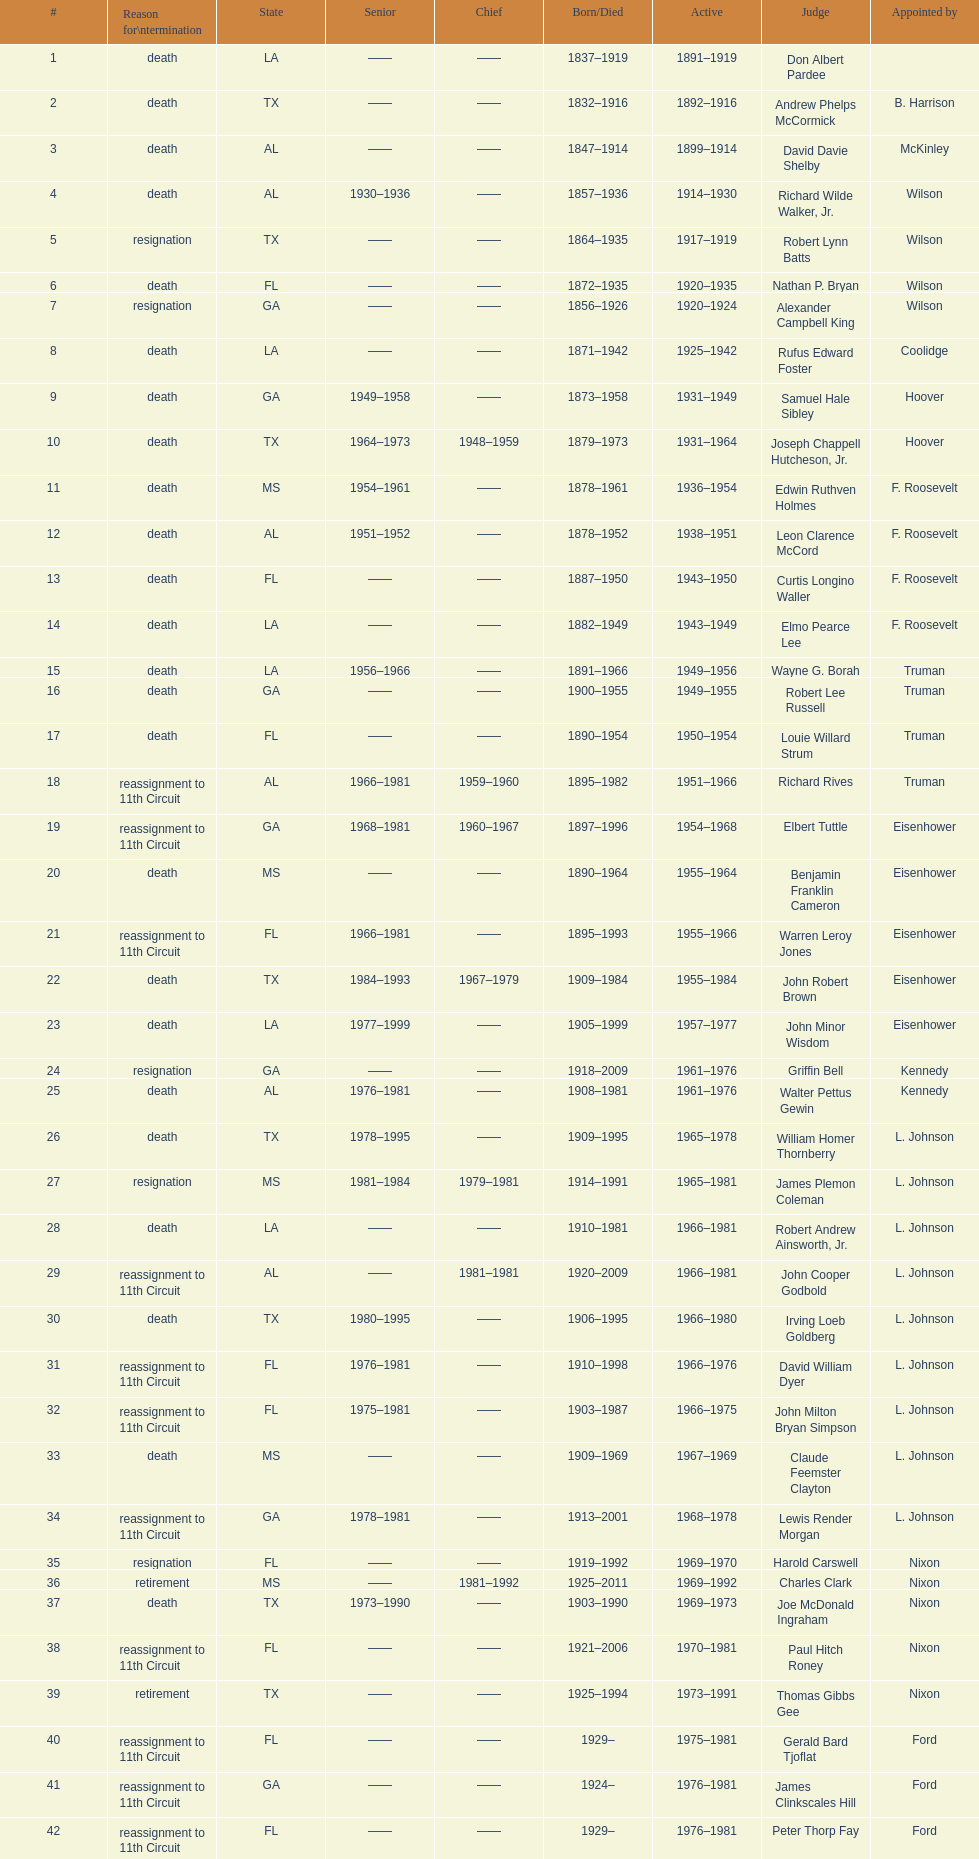Which state has the largest amount of judges to serve? TX. 